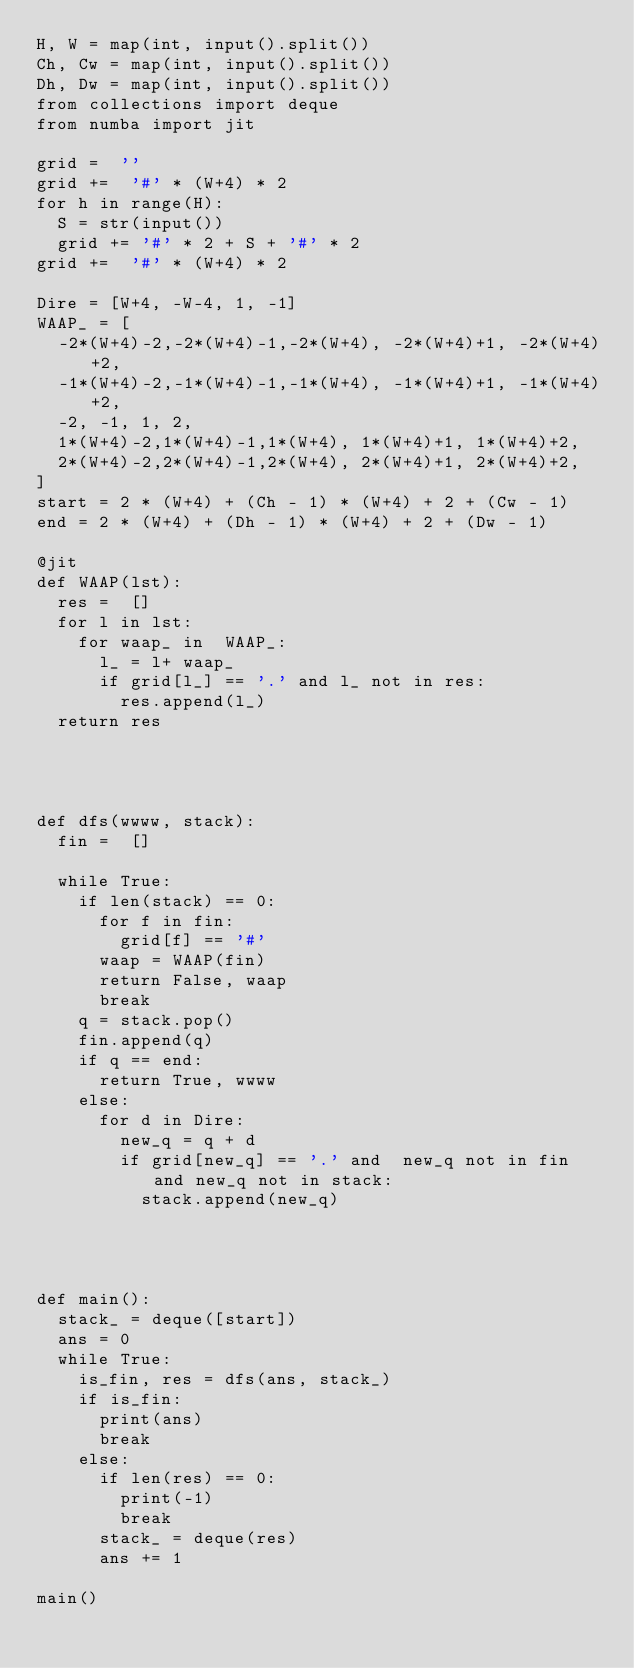Convert code to text. <code><loc_0><loc_0><loc_500><loc_500><_Python_>H, W = map(int, input().split())
Ch, Cw = map(int, input().split())
Dh, Dw = map(int, input().split())
from collections import deque
from numba import jit

grid =  ''
grid +=  '#' * (W+4) * 2
for h in range(H):
  S = str(input())
  grid += '#' * 2 + S + '#' * 2
grid +=  '#' * (W+4) * 2

Dire = [W+4, -W-4, 1, -1]
WAAP_ = [
  -2*(W+4)-2,-2*(W+4)-1,-2*(W+4), -2*(W+4)+1, -2*(W+4)+2, 
  -1*(W+4)-2,-1*(W+4)-1,-1*(W+4), -1*(W+4)+1, -1*(W+4)+2, 
  -2, -1, 1, 2,
  1*(W+4)-2,1*(W+4)-1,1*(W+4), 1*(W+4)+1, 1*(W+4)+2, 
  2*(W+4)-2,2*(W+4)-1,2*(W+4), 2*(W+4)+1, 2*(W+4)+2, 
]
start = 2 * (W+4) + (Ch - 1) * (W+4) + 2 + (Cw - 1)
end = 2 * (W+4) + (Dh - 1) * (W+4) + 2 + (Dw - 1)

@jit
def WAAP(lst):
  res =  []
  for l in lst:
    for waap_ in  WAAP_:
      l_ = l+ waap_
      if grid[l_] == '.' and l_ not in res:
        res.append(l_)
  return res
        
        
    

def dfs(wwww, stack):
  fin =  []
  
  while True:
    if len(stack) == 0:
      for f in fin:
        grid[f] == '#'
      waap = WAAP(fin)
      return False, waap
      break
    q = stack.pop()
    fin.append(q)
    if q == end:
      return True, wwww
    else:
      for d in Dire:
        new_q = q + d
        if grid[new_q] == '.' and  new_q not in fin and new_q not in stack:
          stack.append(new_q)
          
          
          
          
def main():
  stack_ = deque([start])
  ans = 0
  while True:
    is_fin, res = dfs(ans, stack_)
    if is_fin:
      print(ans)
      break
    else:
      if len(res) == 0:
        print(-1)
        break
      stack_ = deque(res)
      ans += 1
      
main()

</code> 